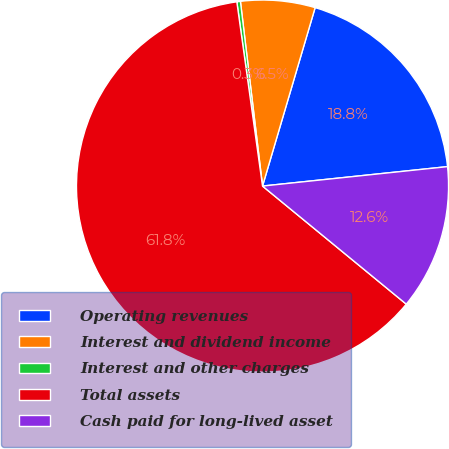<chart> <loc_0><loc_0><loc_500><loc_500><pie_chart><fcel>Operating revenues<fcel>Interest and dividend income<fcel>Interest and other charges<fcel>Total assets<fcel>Cash paid for long-lived asset<nl><fcel>18.77%<fcel>6.46%<fcel>0.31%<fcel>61.85%<fcel>12.61%<nl></chart> 